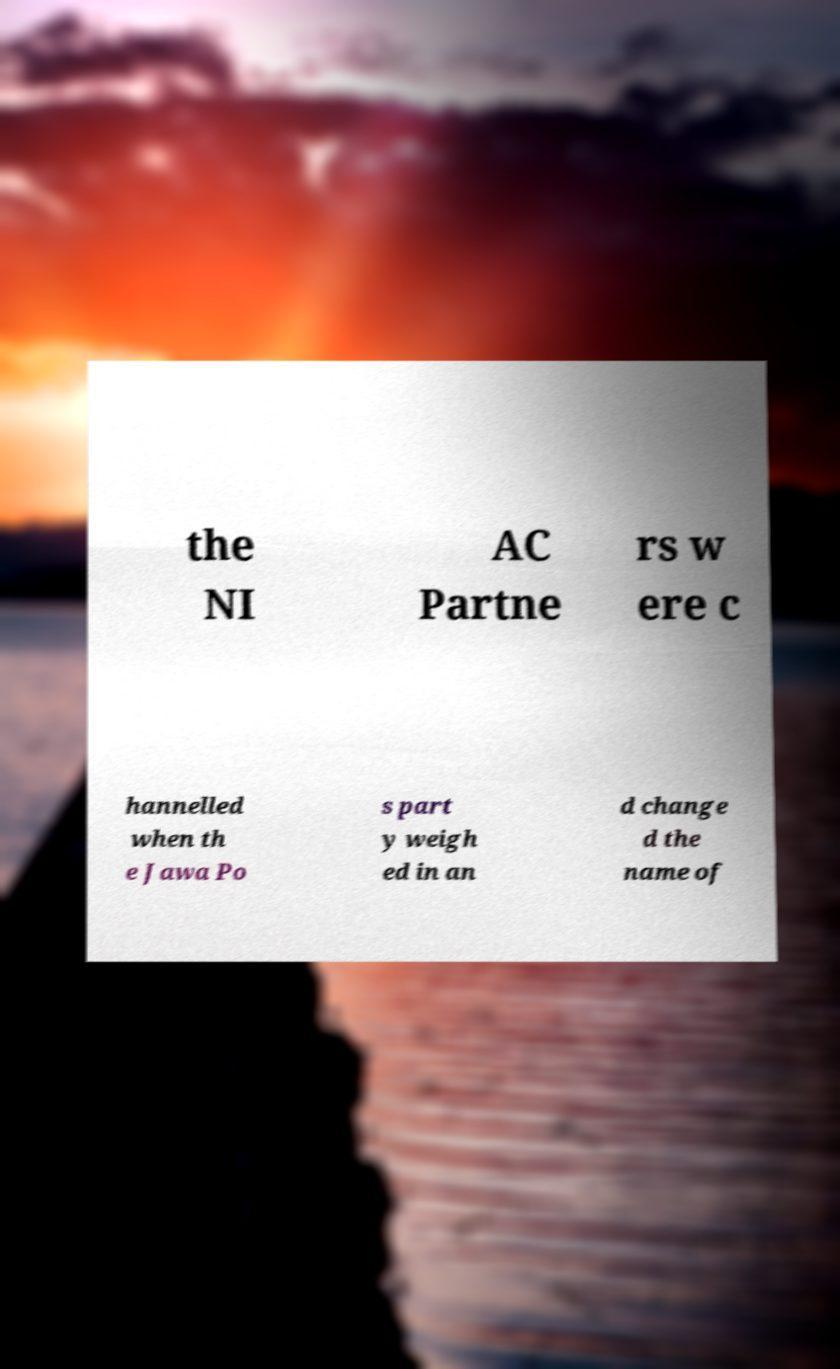Please identify and transcribe the text found in this image. the NI AC Partne rs w ere c hannelled when th e Jawa Po s part y weigh ed in an d change d the name of 